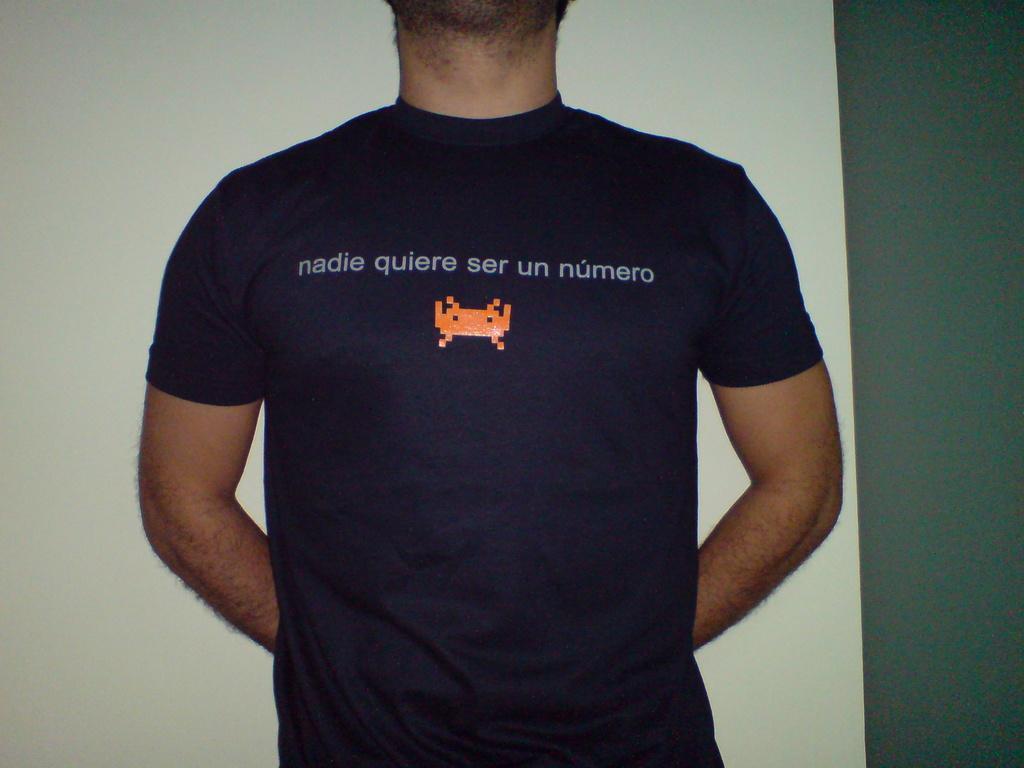In one or two sentences, can you explain what this image depicts? In the image we can see a man standing, wearing T-shirt and there is a text on the T-shirt, and the background is white. 